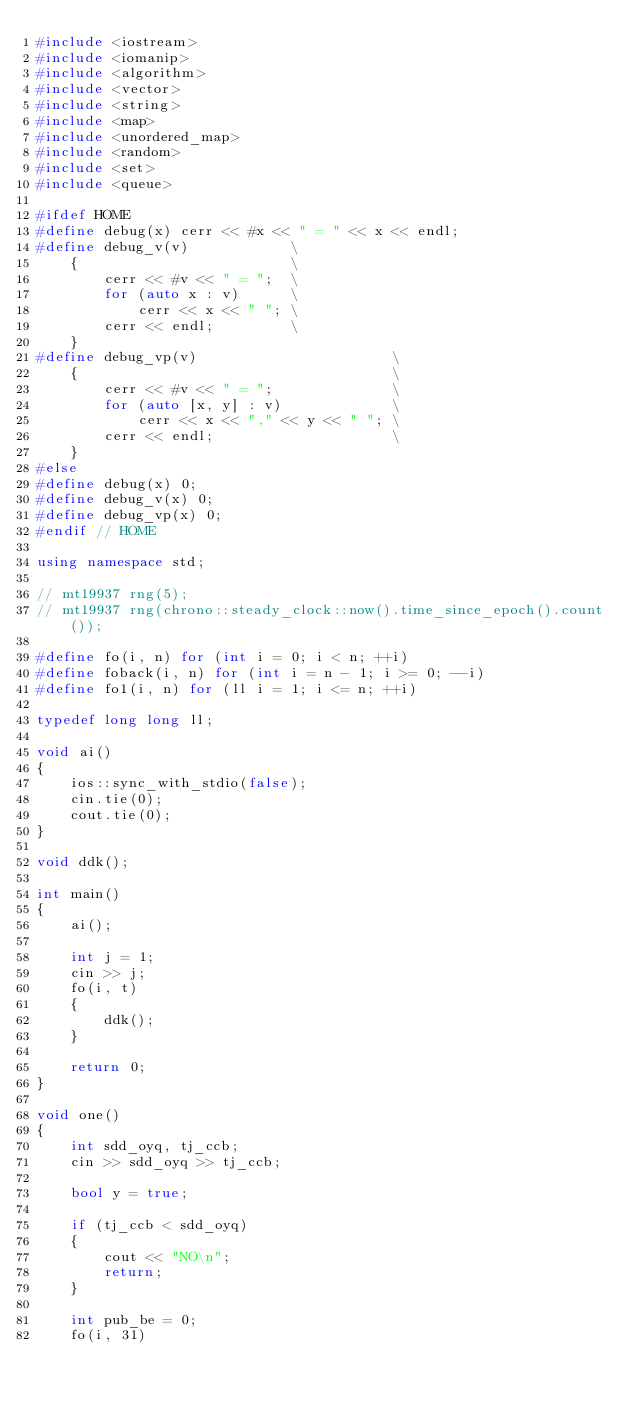<code> <loc_0><loc_0><loc_500><loc_500><_C++_>#include <iostream>
#include <iomanip>
#include <algorithm>
#include <vector>
#include <string>
#include <map>
#include <unordered_map>
#include <random>
#include <set>
#include <queue>

#ifdef HOME
#define debug(x) cerr << #x << " = " << x << endl;
#define debug_v(v)            \
    {                         \
        cerr << #v << " = ";  \
        for (auto x : v)      \
            cerr << x << " "; \
        cerr << endl;         \
    }
#define debug_vp(v)                       \
    {                                     \
        cerr << #v << " = ";              \
        for (auto [x, y] : v)             \
            cerr << x << "," << y << " "; \
        cerr << endl;                     \
    }
#else
#define debug(x) 0;
#define debug_v(x) 0;
#define debug_vp(x) 0;
#endif // HOME

using namespace std;

// mt19937 rng(5);
// mt19937 rng(chrono::steady_clock::now().time_since_epoch().count());

#define fo(i, n) for (int i = 0; i < n; ++i)
#define foback(i, n) for (int i = n - 1; i >= 0; --i)
#define fo1(i, n) for (ll i = 1; i <= n; ++i)

typedef long long ll;

void ai()
{
    ios::sync_with_stdio(false);
    cin.tie(0);
    cout.tie(0);
}

void ddk();

int main()
{
    ai();

    int j = 1;
    cin >> j;
    fo(i, t)
    {
        ddk();
    }

    return 0;
}

void one()
{
    int sdd_oyq, tj_ccb;
    cin >> sdd_oyq >> tj_ccb;

    bool y = true;

    if (tj_ccb < sdd_oyq)
    {
        cout << "NO\n";
        return;
    }

    int pub_be = 0;
    fo(i, 31)</code> 